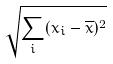Convert formula to latex. <formula><loc_0><loc_0><loc_500><loc_500>\sqrt { \sum _ { i } ( x _ { i } - \overline { x } ) ^ { 2 } }</formula> 